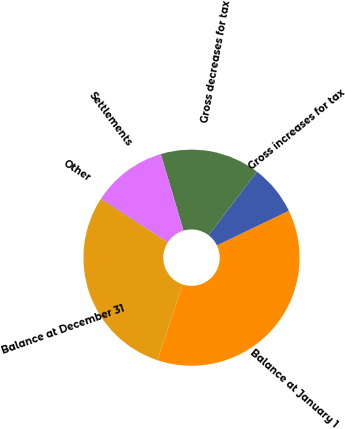<chart> <loc_0><loc_0><loc_500><loc_500><pie_chart><fcel>Balance at January 1<fcel>Gross increases for tax<fcel>Gross decreases for tax<fcel>Settlements<fcel>Other<fcel>Balance at December 31<nl><fcel>37.24%<fcel>7.5%<fcel>14.94%<fcel>11.22%<fcel>0.07%<fcel>29.03%<nl></chart> 